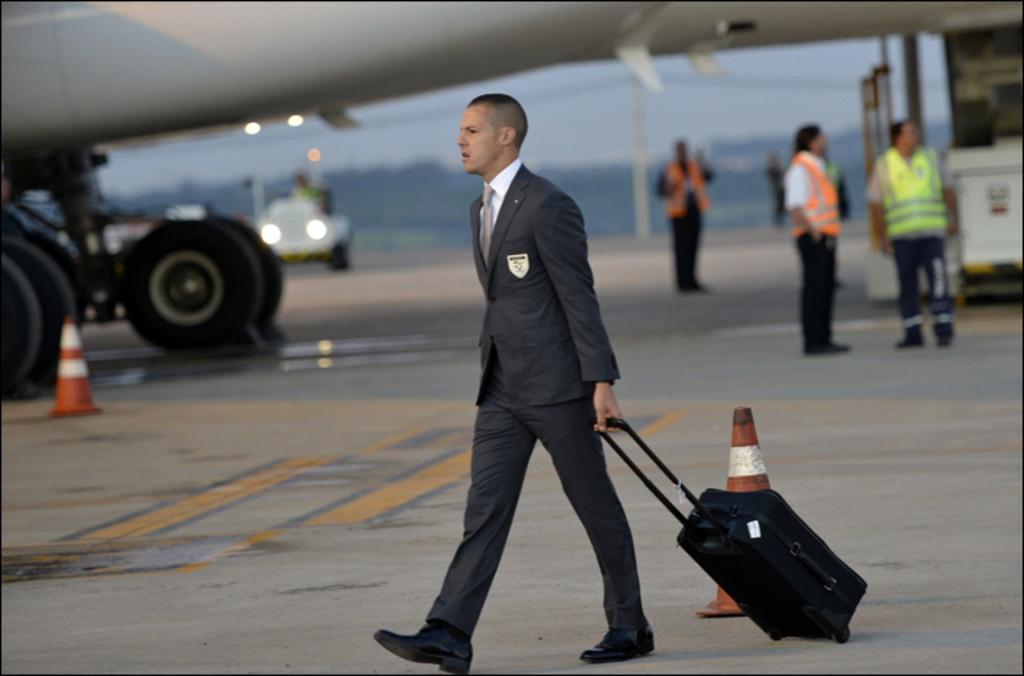Describe this image in one or two sentences. In the image there is a man carrying a luggage and behind the man there is an airplane and around the airplane there are some other people. 